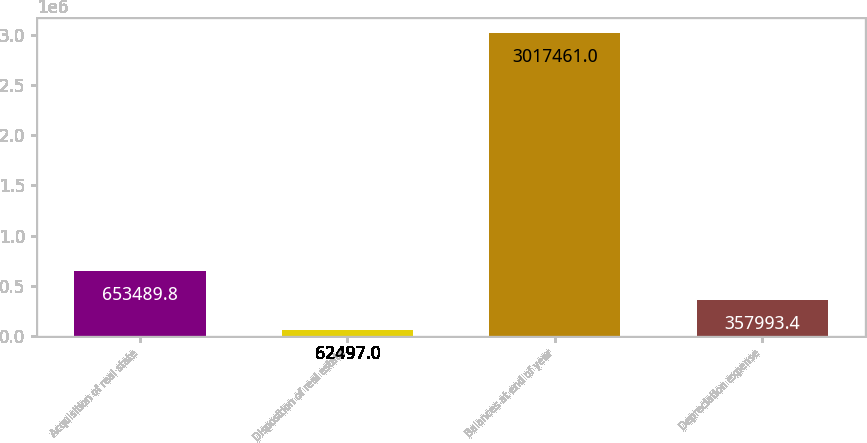Convert chart to OTSL. <chart><loc_0><loc_0><loc_500><loc_500><bar_chart><fcel>Acquisition of real state<fcel>Disposition of real estate<fcel>Balances at end of year<fcel>Depreciation expense<nl><fcel>653490<fcel>62497<fcel>3.01746e+06<fcel>357993<nl></chart> 